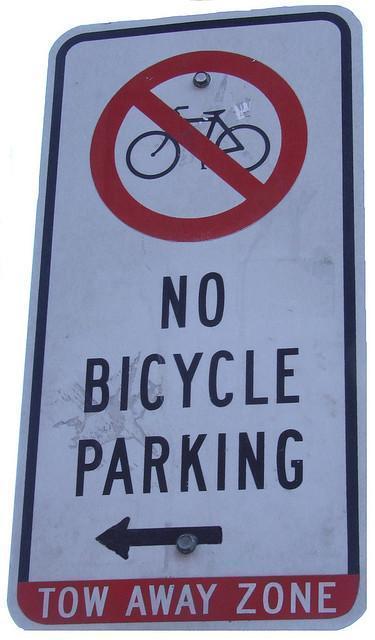How many cars are in the picture?
Give a very brief answer. 0. How many donuts are in the picture?
Give a very brief answer. 0. 